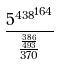<formula> <loc_0><loc_0><loc_500><loc_500>\frac { { 5 ^ { 4 3 8 } } ^ { 1 6 4 } } { \frac { \frac { 3 8 6 } { 4 9 3 } } { 3 7 0 } }</formula> 